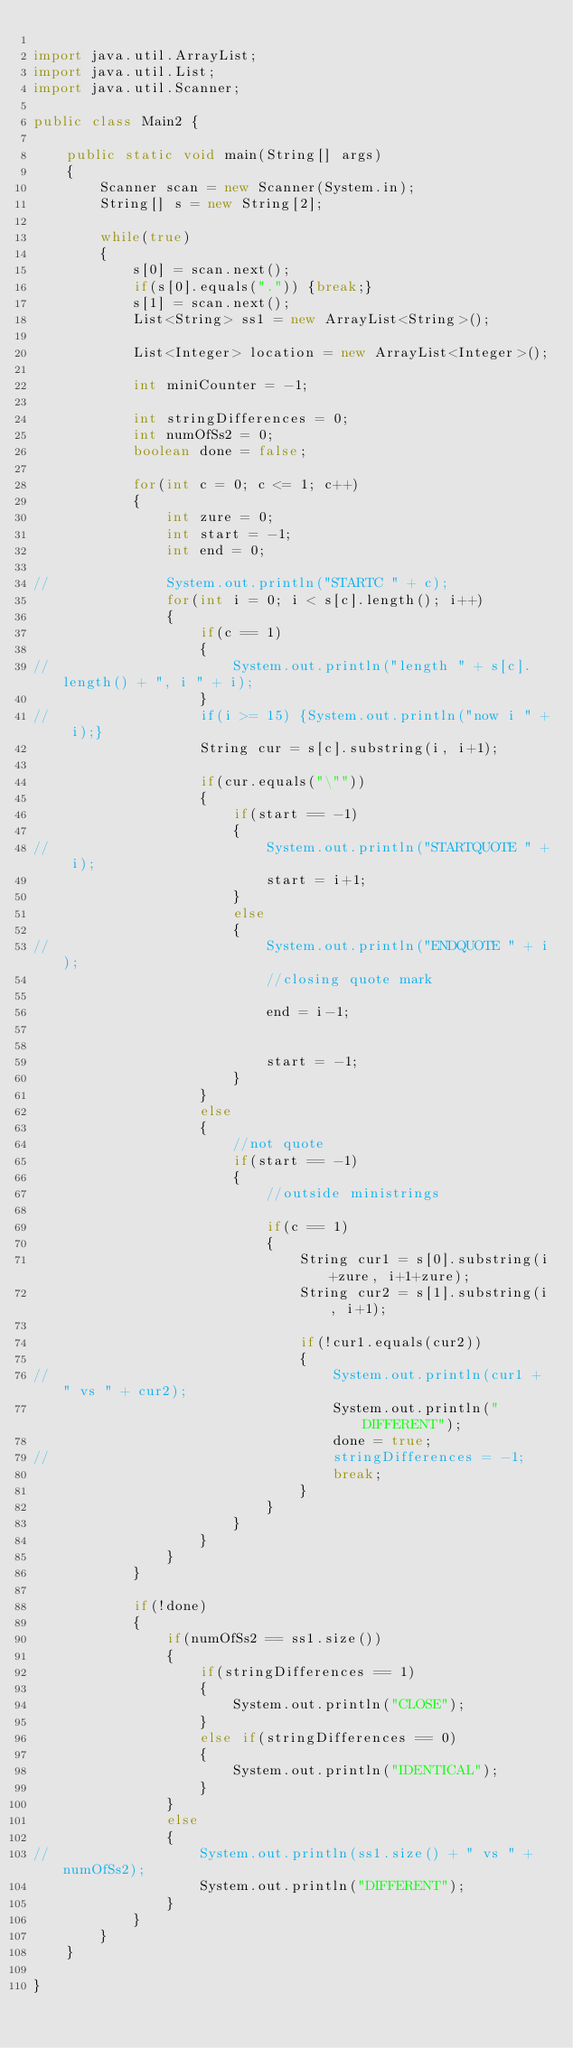<code> <loc_0><loc_0><loc_500><loc_500><_Java_>
import java.util.ArrayList;
import java.util.List;
import java.util.Scanner;

public class Main2 {

	public static void main(String[] args) 
	{
		Scanner scan = new Scanner(System.in);
		String[] s = new String[2];
		
		while(true)
		{
			s[0] = scan.next();
			if(s[0].equals(".")) {break;}
			s[1] = scan.next();
			List<String> ss1 = new ArrayList<String>();
			
			List<Integer> location = new ArrayList<Integer>();
			
			int miniCounter = -1;
			
			int stringDifferences = 0;
			int numOfSs2 = 0;
			boolean done = false;
			
			for(int c = 0; c <= 1; c++)
			{
				int zure = 0;
				int start = -1;
				int end = 0;
				
//				System.out.println("STARTC " + c);
				for(int i = 0; i < s[c].length(); i++)
				{
					if(c == 1)
					{
//						System.out.println("length " + s[c].length() + ", i " + i);
					}
//					if(i >= 15) {System.out.println("now i " + i);}
					String cur = s[c].substring(i, i+1);
					
					if(cur.equals("\""))
					{
						if(start == -1)
						{
//							System.out.println("STARTQUOTE " + i);
							start = i+1;
						}
						else
						{
//							System.out.println("ENDQUOTE " + i);
							//closing quote mark
							
							end = i-1;

							
							start = -1;
						}
					}
					else
					{
						//not quote
						if(start == -1)
						{
							//outside ministrings
							
							if(c == 1)
							{
								String cur1 = s[0].substring(i+zure, i+1+zure);
								String cur2 = s[1].substring(i, i+1);
								
								if(!cur1.equals(cur2))
								{
//									System.out.println(cur1 + " vs " + cur2);
									System.out.println("DIFFERENT");
									done = true;
//									stringDifferences = -1;
									break;
								}
							}
						}
					}
				}
			}
			
			if(!done)
			{
				if(numOfSs2 == ss1.size())
				{
					if(stringDifferences == 1)
					{
						System.out.println("CLOSE");
					}
					else if(stringDifferences == 0)
					{
						System.out.println("IDENTICAL");
					}
				}
				else
				{
//					System.out.println(ss1.size() + " vs " + numOfSs2);
					System.out.println("DIFFERENT");
				}
			}
		}
	}

}

</code> 